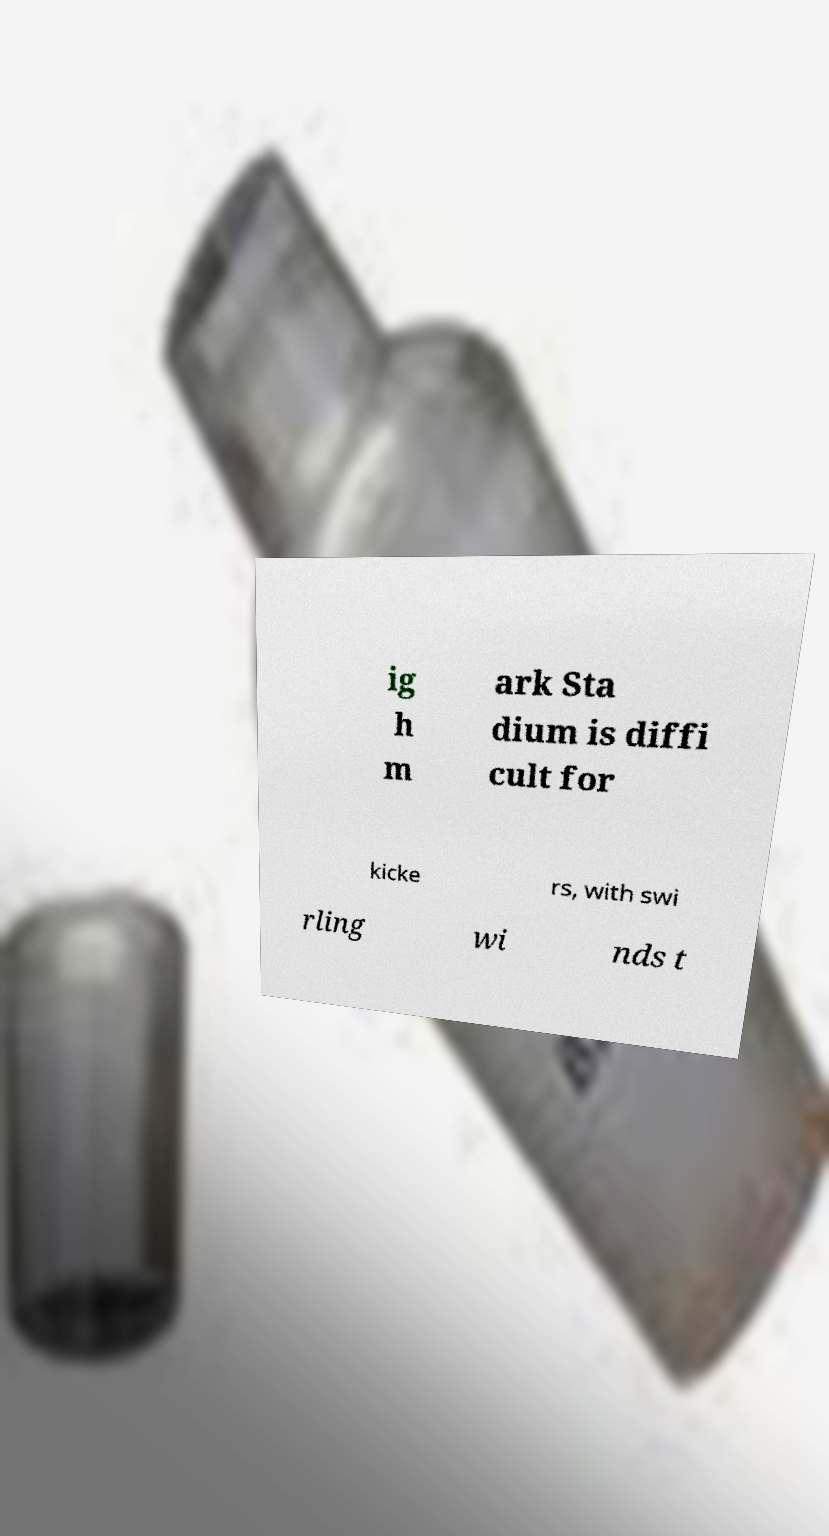Please identify and transcribe the text found in this image. ig h m ark Sta dium is diffi cult for kicke rs, with swi rling wi nds t 